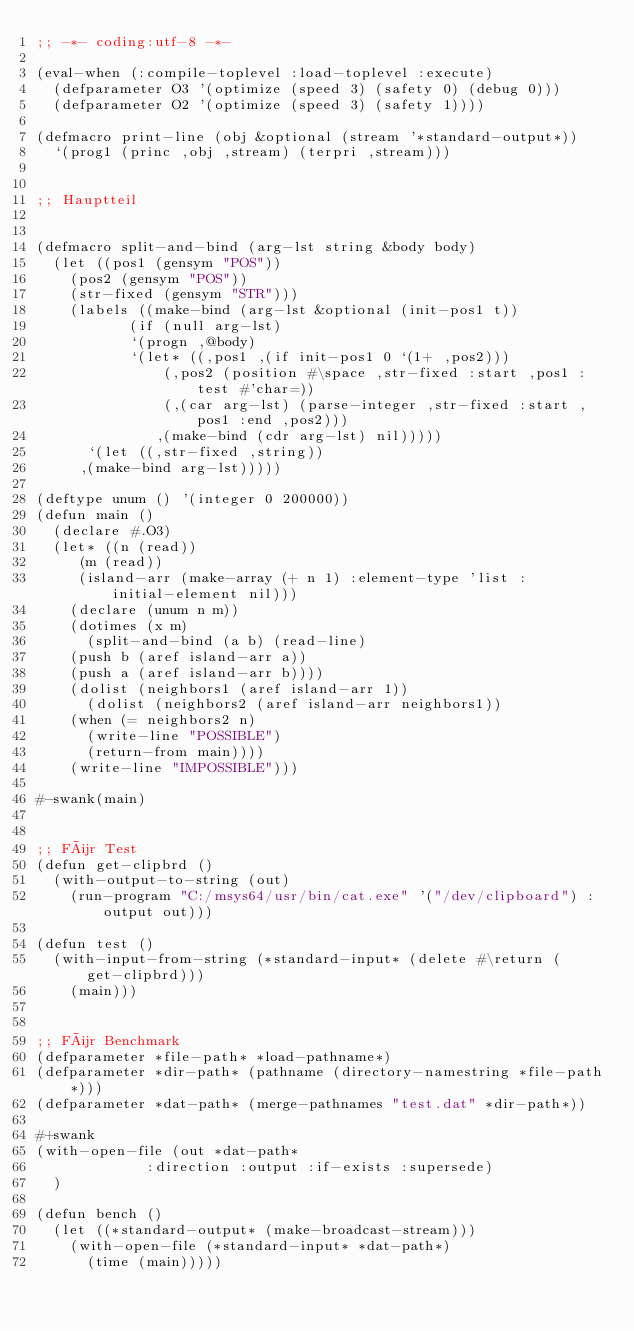Convert code to text. <code><loc_0><loc_0><loc_500><loc_500><_Lisp_>;; -*- coding:utf-8 -*-

(eval-when (:compile-toplevel :load-toplevel :execute)
  (defparameter O3 '(optimize (speed 3) (safety 0) (debug 0)))
  (defparameter O2 '(optimize (speed 3) (safety 1))))

(defmacro print-line (obj &optional (stream '*standard-output*))
  `(prog1 (princ ,obj ,stream) (terpri ,stream)))


;; Hauptteil


(defmacro split-and-bind (arg-lst string &body body)
  (let ((pos1 (gensym "POS"))
	(pos2 (gensym "POS"))
	(str-fixed (gensym "STR")))
    (labels ((make-bind (arg-lst &optional (init-pos1 t))
	       (if (null arg-lst)
		   `(progn ,@body)
		   `(let* ((,pos1 ,(if init-pos1 0 `(1+ ,pos2)))
			   (,pos2 (position #\space ,str-fixed :start ,pos1 :test #'char=))
			   (,(car arg-lst) (parse-integer ,str-fixed :start ,pos1 :end ,pos2)))
		      ,(make-bind (cdr arg-lst) nil)))))
      `(let ((,str-fixed ,string))
	 ,(make-bind arg-lst)))))

(deftype unum () '(integer 0 200000))
(defun main ()
  (declare #.O3)
  (let* ((n (read))
	 (m (read))
	 (island-arr (make-array (+ n 1) :element-type 'list :initial-element nil)))
    (declare (unum n m))
    (dotimes (x m)
      (split-and-bind (a b) (read-line)
	(push b (aref island-arr a))
	(push a (aref island-arr b))))
    (dolist (neighbors1 (aref island-arr 1))
      (dolist (neighbors2 (aref island-arr neighbors1))
	(when (= neighbors2 n)
	  (write-line "POSSIBLE")
	  (return-from main))))
    (write-line "IMPOSSIBLE")))

#-swank(main)


;; Für Test
(defun get-clipbrd ()
  (with-output-to-string (out)
    (run-program "C:/msys64/usr/bin/cat.exe" '("/dev/clipboard") :output out)))

(defun test ()
  (with-input-from-string (*standard-input* (delete #\return (get-clipbrd)))
    (main)))


;; Für Benchmark
(defparameter *file-path* *load-pathname*)
(defparameter *dir-path* (pathname (directory-namestring *file-path*)))
(defparameter *dat-path* (merge-pathnames "test.dat" *dir-path*))

#+swank
(with-open-file (out *dat-path*
		     :direction :output :if-exists :supersede)
  )

(defun bench ()
  (let ((*standard-output* (make-broadcast-stream)))
    (with-open-file (*standard-input* *dat-path*)
      (time (main)))))
</code> 